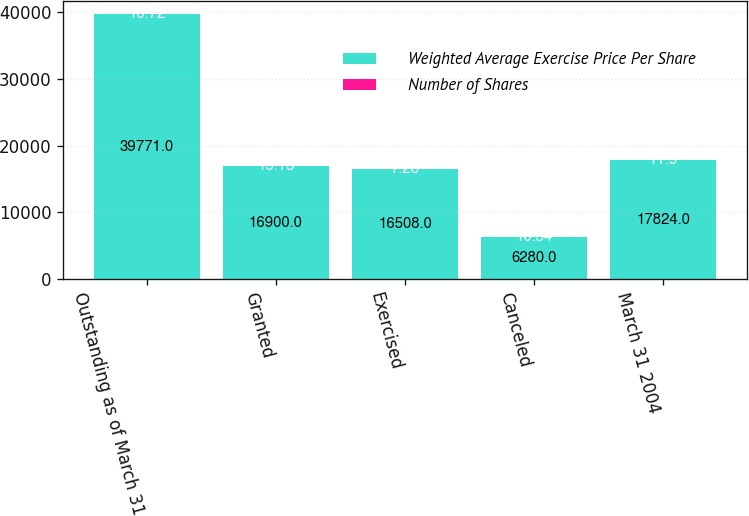<chart> <loc_0><loc_0><loc_500><loc_500><stacked_bar_chart><ecel><fcel>Outstanding as of March 31<fcel>Granted<fcel>Exercised<fcel>Canceled<fcel>March 31 2004<nl><fcel>Weighted Average Exercise Price Per Share<fcel>39771<fcel>16900<fcel>16508<fcel>6280<fcel>17824<nl><fcel>Number of Shares<fcel>16.72<fcel>15.13<fcel>7.28<fcel>10.34<fcel>11.9<nl></chart> 